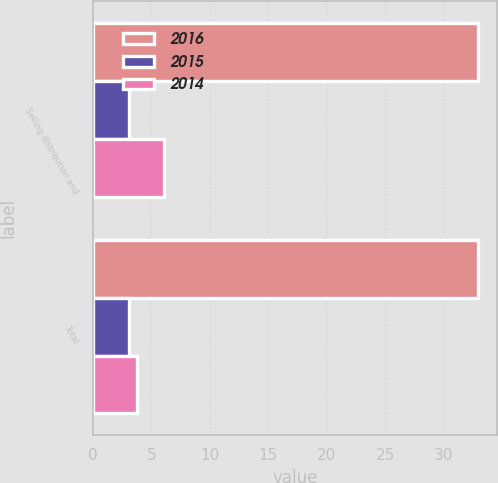Convert chart. <chart><loc_0><loc_0><loc_500><loc_500><stacked_bar_chart><ecel><fcel>Selling distribution and<fcel>Total<nl><fcel>2016<fcel>32.9<fcel>32.9<nl><fcel>2015<fcel>3.1<fcel>3.1<nl><fcel>2014<fcel>6.1<fcel>3.8<nl></chart> 